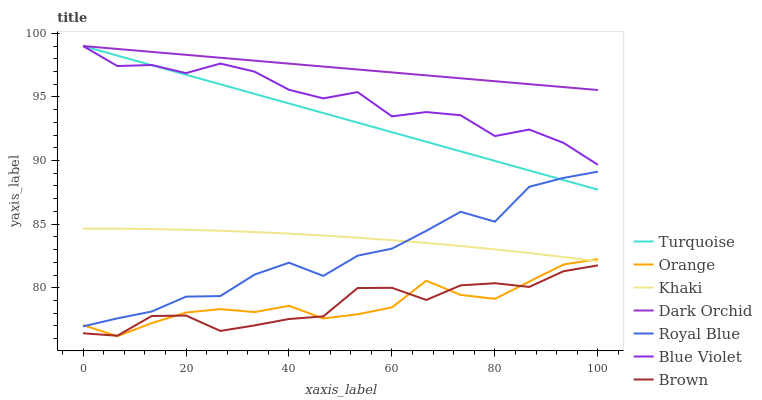Does Brown have the minimum area under the curve?
Answer yes or no. Yes. Does Dark Orchid have the maximum area under the curve?
Answer yes or no. Yes. Does Turquoise have the minimum area under the curve?
Answer yes or no. No. Does Turquoise have the maximum area under the curve?
Answer yes or no. No. Is Dark Orchid the smoothest?
Answer yes or no. Yes. Is Royal Blue the roughest?
Answer yes or no. Yes. Is Turquoise the smoothest?
Answer yes or no. No. Is Turquoise the roughest?
Answer yes or no. No. Does Turquoise have the lowest value?
Answer yes or no. No. Does Blue Violet have the highest value?
Answer yes or no. Yes. Does Khaki have the highest value?
Answer yes or no. No. Is Khaki less than Turquoise?
Answer yes or no. Yes. Is Blue Violet greater than Brown?
Answer yes or no. Yes. Does Turquoise intersect Dark Orchid?
Answer yes or no. Yes. Is Turquoise less than Dark Orchid?
Answer yes or no. No. Is Turquoise greater than Dark Orchid?
Answer yes or no. No. Does Khaki intersect Turquoise?
Answer yes or no. No. 